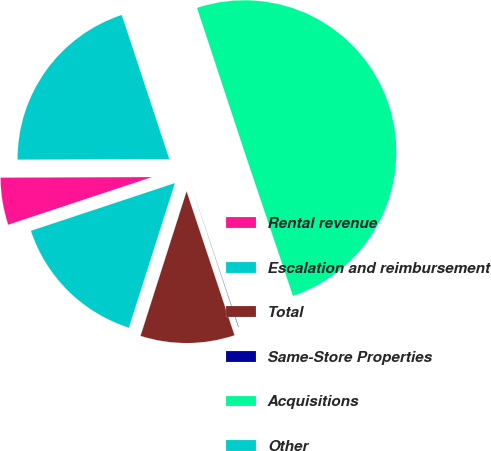<chart> <loc_0><loc_0><loc_500><loc_500><pie_chart><fcel>Rental revenue<fcel>Escalation and reimbursement<fcel>Total<fcel>Same-Store Properties<fcel>Acquisitions<fcel>Other<nl><fcel>5.03%<fcel>15.0%<fcel>10.02%<fcel>0.05%<fcel>49.9%<fcel>19.99%<nl></chart> 